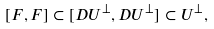Convert formula to latex. <formula><loc_0><loc_0><loc_500><loc_500>[ F , F ] \subset [ D U ^ { \perp } , D U ^ { \perp } ] \subset U ^ { \perp } ,</formula> 